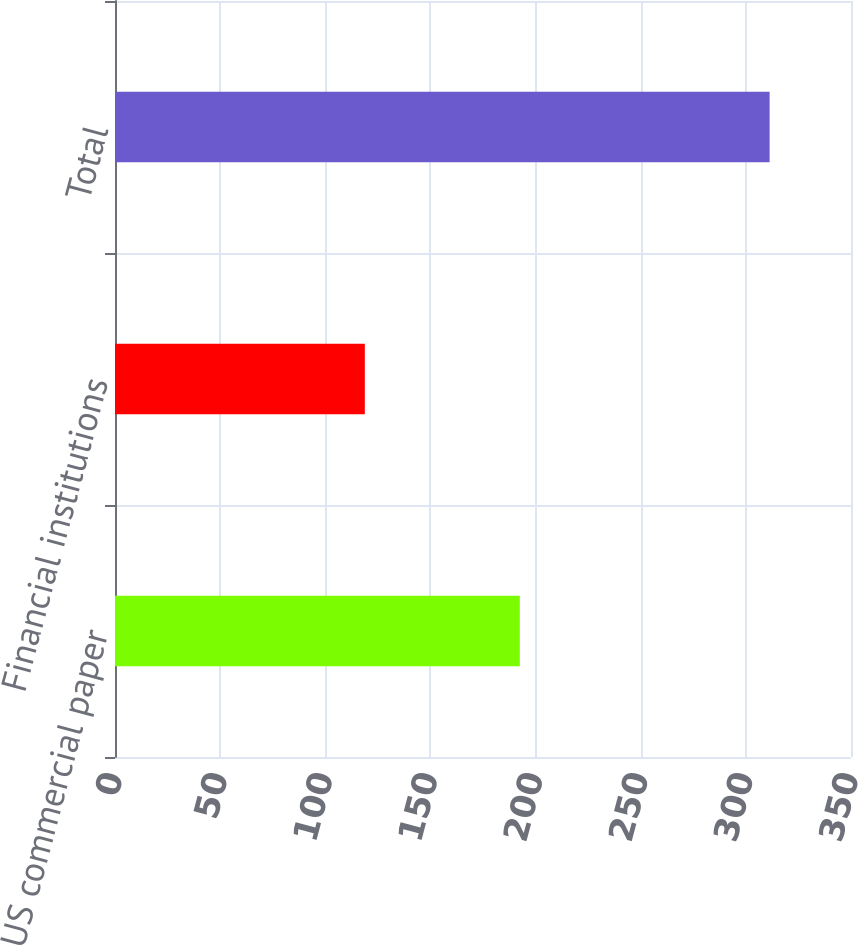Convert chart to OTSL. <chart><loc_0><loc_0><loc_500><loc_500><bar_chart><fcel>US commercial paper<fcel>Financial institutions<fcel>Total<nl><fcel>192.5<fcel>118.8<fcel>311.3<nl></chart> 